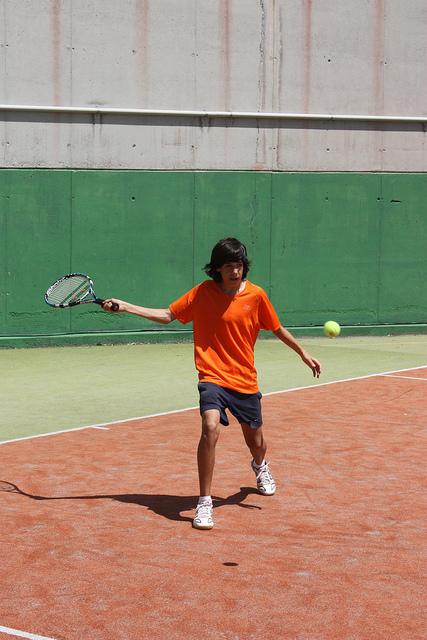Is he left handed?
Concise answer only. No. Is the boy playing professionally?
Be succinct. No. What is the person about to hit?
Answer briefly. Tennis ball. 